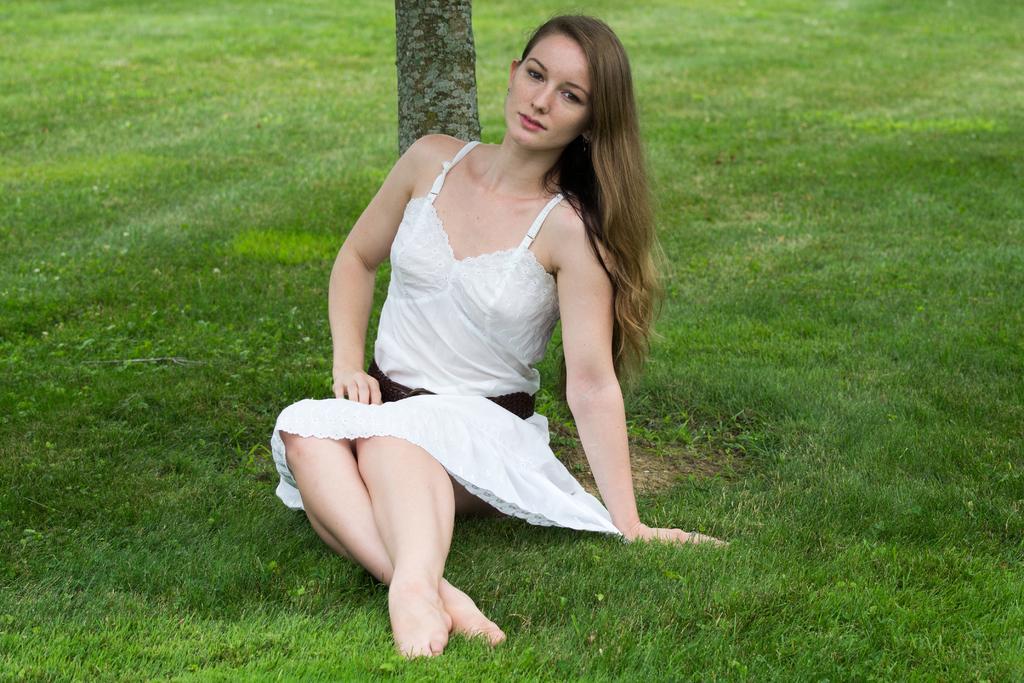Describe this image in one or two sentences. In this picture there is a girl in the center of the image, on a grass floor and there is grassland around the area of the image, there is a trunk in the center of the image. 